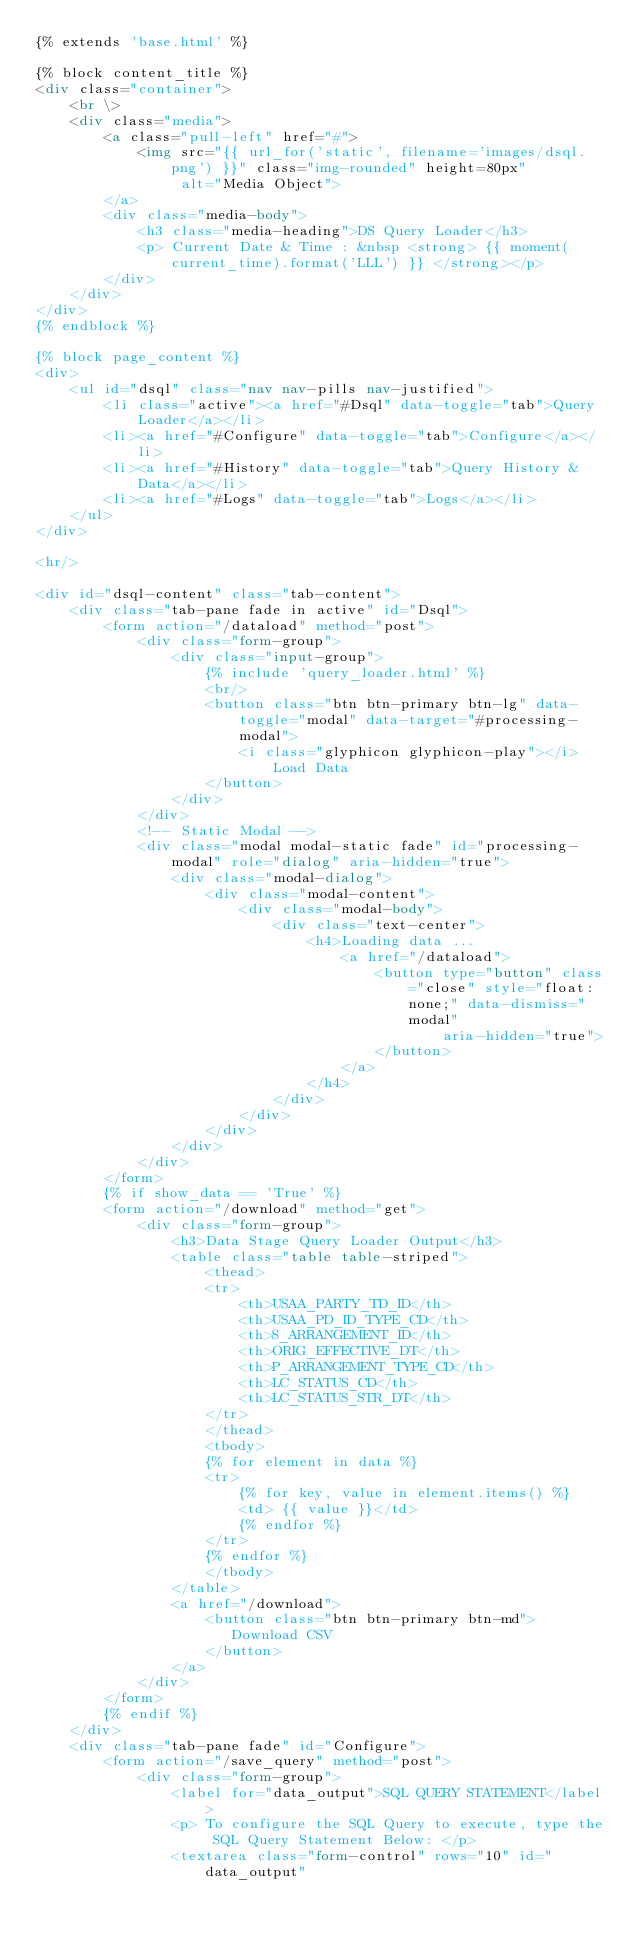Convert code to text. <code><loc_0><loc_0><loc_500><loc_500><_HTML_>{% extends 'base.html' %}

{% block content_title %}
<div class="container">
    <br \>
    <div class="media">
        <a class="pull-left" href="#">
            <img src="{{ url_for('static', filename='images/dsql.png') }}" class="img-rounded" height=80px"
                 alt="Media Object">
        </a>
        <div class="media-body">
            <h3 class="media-heading">DS Query Loader</h3>
            <p> Current Date & Time : &nbsp <strong> {{ moment(current_time).format('LLL') }} </strong></p>
        </div>
    </div>
</div>
{% endblock %}

{% block page_content %}
<div>
    <ul id="dsql" class="nav nav-pills nav-justified">
        <li class="active"><a href="#Dsql" data-toggle="tab">Query Loader</a></li>
        <li><a href="#Configure" data-toggle="tab">Configure</a></li>
        <li><a href="#History" data-toggle="tab">Query History & Data</a></li>
        <li><a href="#Logs" data-toggle="tab">Logs</a></li>
    </ul>
</div>

<hr/>

<div id="dsql-content" class="tab-content">
    <div class="tab-pane fade in active" id="Dsql">
        <form action="/dataload" method="post">
            <div class="form-group">
                <div class="input-group">
                    {% include 'query_loader.html' %}
                    <br/>
                    <button class="btn btn-primary btn-lg" data-toggle="modal" data-target="#processing-modal">
                        <i class="glyphicon glyphicon-play"></i> Load Data
                    </button>
                </div>
            </div>
            <!-- Static Modal -->
            <div class="modal modal-static fade" id="processing-modal" role="dialog" aria-hidden="true">
                <div class="modal-dialog">
                    <div class="modal-content">
                        <div class="modal-body">
                            <div class="text-center">
                                <h4>Loading data ...
                                    <a href="/dataload">
                                        <button type="button" class="close" style="float: none;" data-dismiss="modal"
                                                aria-hidden="true">
                                        </button>
                                    </a>
                                </h4>
                            </div>
                        </div>
                    </div>
                </div>
            </div>
        </form>
        {% if show_data == 'True' %}
        <form action="/download" method="get">
            <div class="form-group">
                <h3>Data Stage Query Loader Output</h3>
                <table class="table table-striped">
                    <thead>
                    <tr>
                        <th>USAA_PARTY_TD_ID</th>
                        <th>USAA_PD_ID_TYPE_CD</th>
                        <th>S_ARRANGEMENT_ID</th>
                        <th>ORIG_EFFECTIVE_DT</th>
                        <th>P_ARRANGEMENT_TYPE_CD</th>
                        <th>LC_STATUS_CD</th>
                        <th>LC_STATUS_STR_DT</th>
                    </tr>
                    </thead>
                    <tbody>
                    {% for element in data %}
                    <tr>
                        {% for key, value in element.items() %}
                        <td> {{ value }}</td>
                        {% endfor %}
                    </tr>
                    {% endfor %}
                    </tbody>
                </table>
                <a href="/download">
                    <button class="btn btn-primary btn-md">
                       Download CSV
                    </button>
                </a>
            </div>
        </form>
        {% endif %}
    </div>
    <div class="tab-pane fade" id="Configure">
        <form action="/save_query" method="post">
            <div class="form-group">
                <label for="data_output">SQL QUERY STATEMENT</label>
                <p> To configure the SQL Query to execute, type the SQL Query Statement Below: </p>
                <textarea class="form-control" rows="10" id="data_output"</code> 